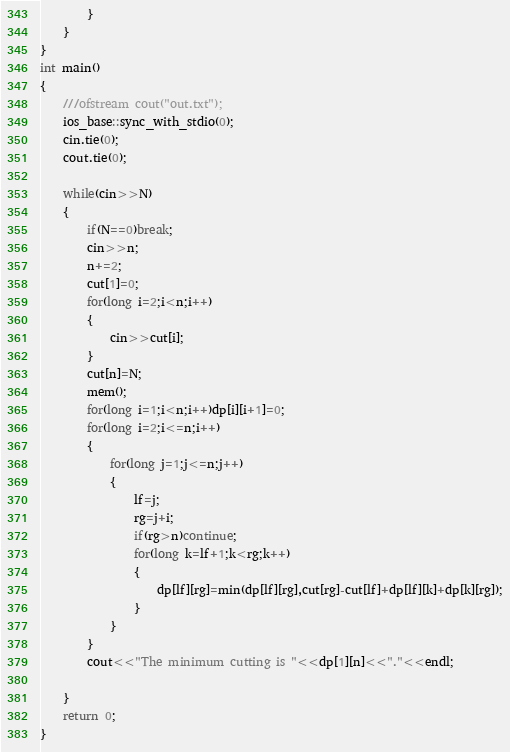Convert code to text. <code><loc_0><loc_0><loc_500><loc_500><_C++_>        }
    }
}
int main()
{
    ///ofstream cout("out.txt");
    ios_base::sync_with_stdio(0);
    cin.tie(0);
    cout.tie(0);

    while(cin>>N)
    {
        if(N==0)break;
        cin>>n;
        n+=2;
        cut[1]=0;
        for(long i=2;i<n;i++)
        {
            cin>>cut[i];
        }
        cut[n]=N;
        mem();
        for(long i=1;i<n;i++)dp[i][i+1]=0;
        for(long i=2;i<=n;i++)
        {
            for(long j=1;j<=n;j++)
            {
                lf=j;
                rg=j+i;
                if(rg>n)continue;
                for(long k=lf+1;k<rg;k++)
                {
                    dp[lf][rg]=min(dp[lf][rg],cut[rg]-cut[lf]+dp[lf][k]+dp[k][rg]);
                }
            }
        }
        cout<<"The minimum cutting is "<<dp[1][n]<<"."<<endl;

    }
    return 0;
}</code> 